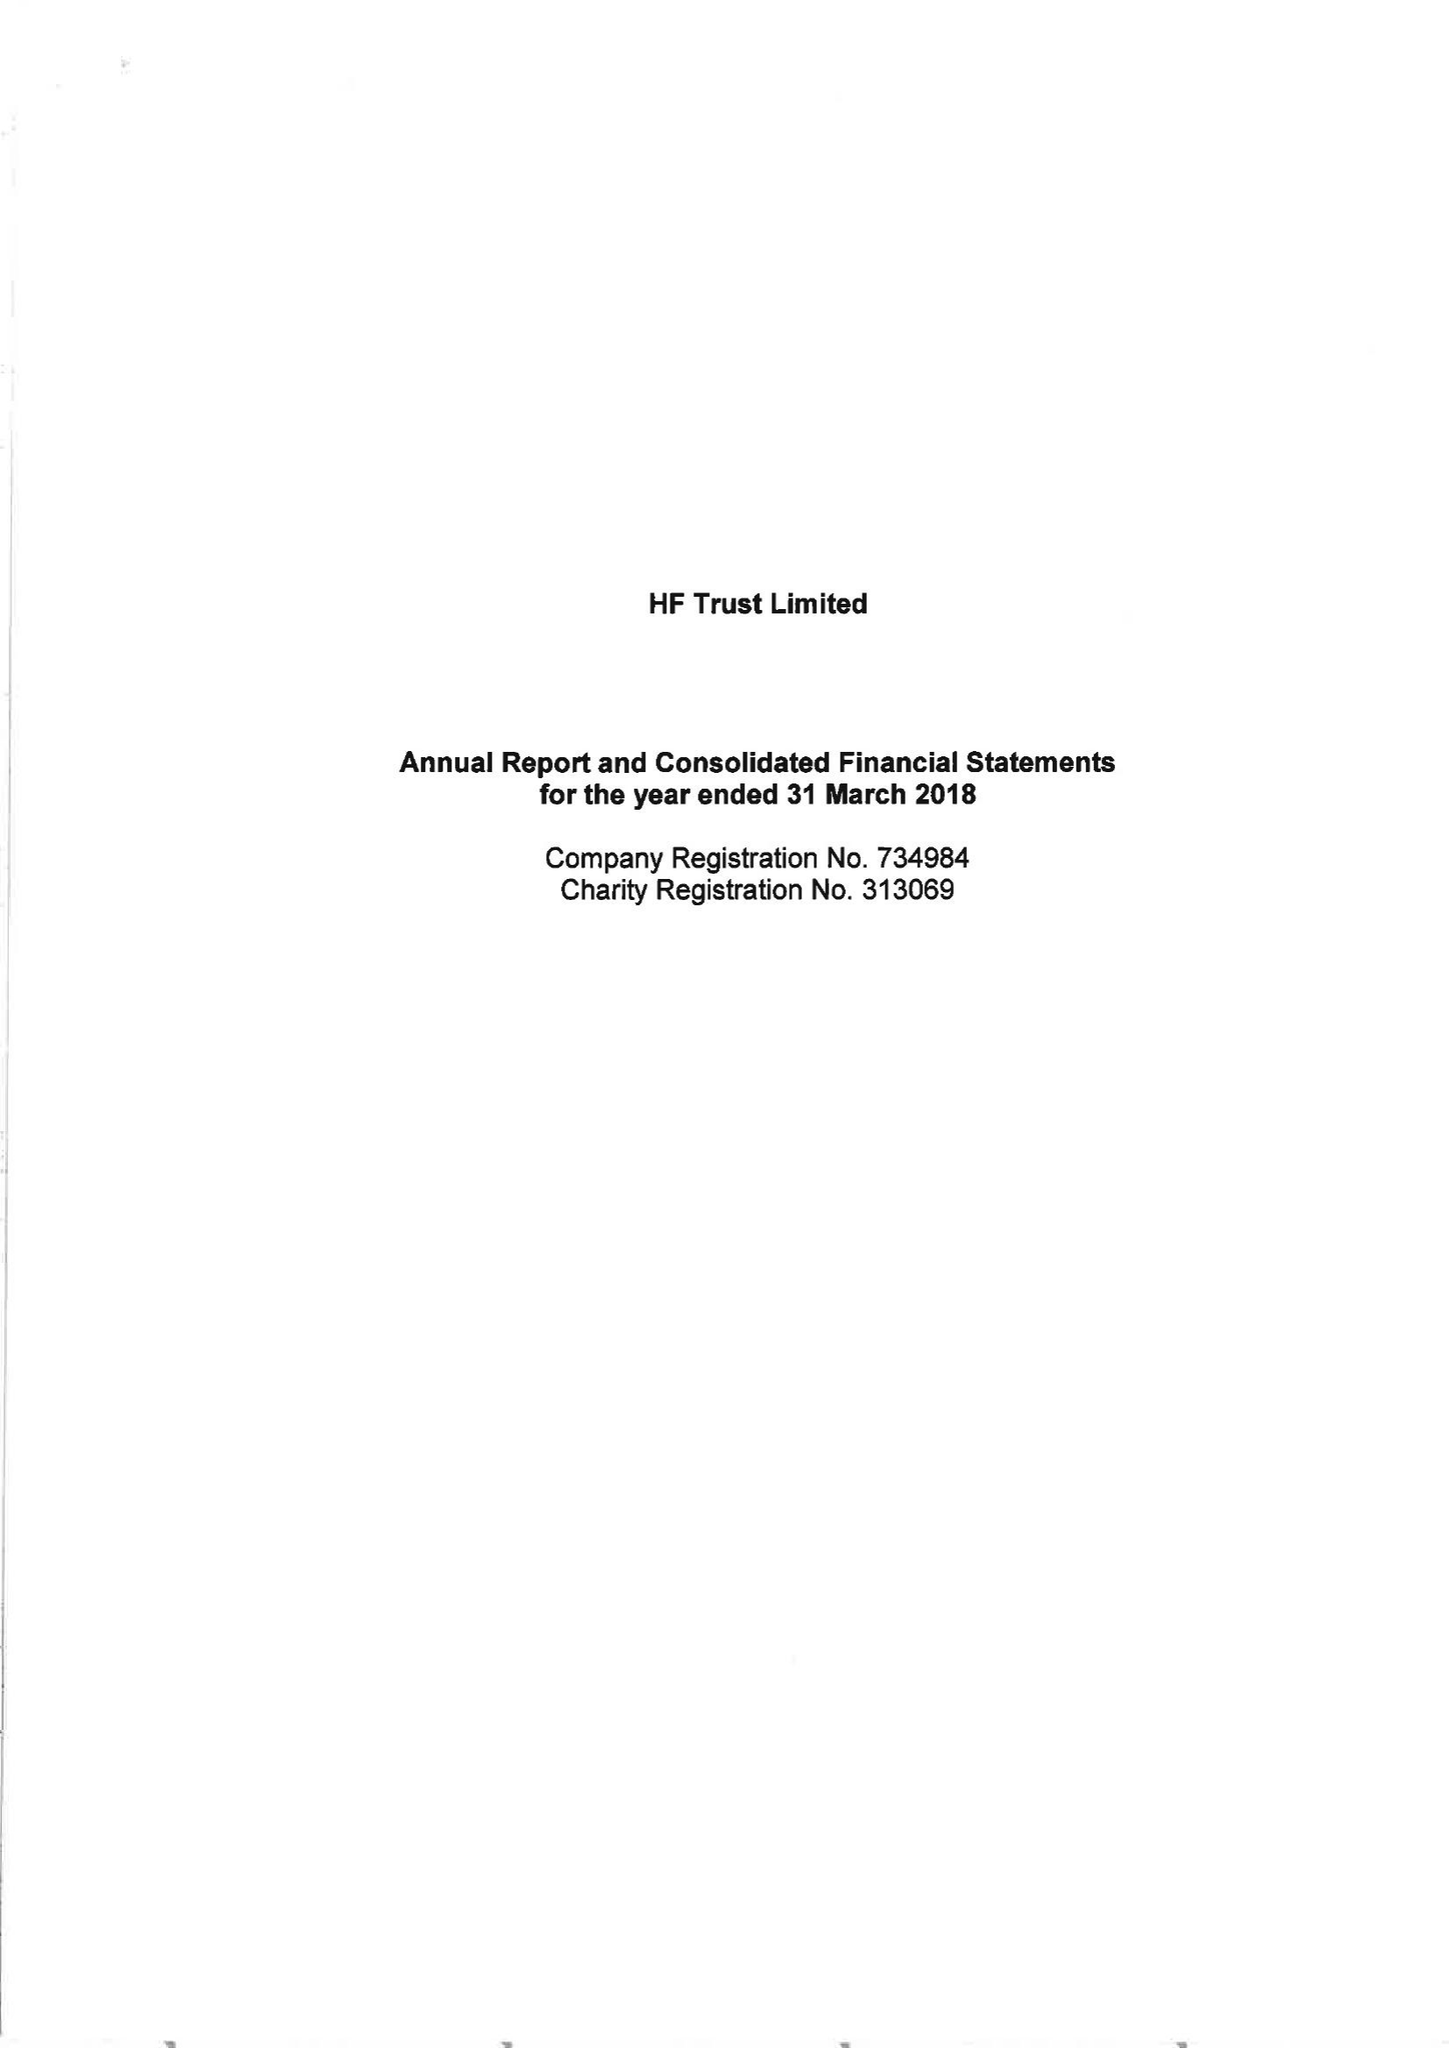What is the value for the charity_number?
Answer the question using a single word or phrase. 313069 